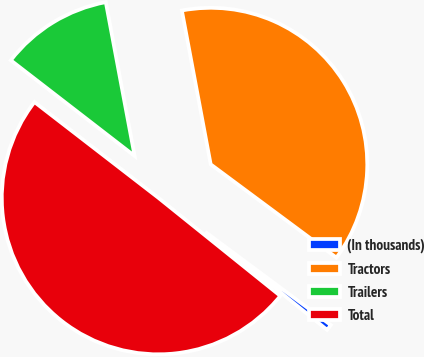Convert chart. <chart><loc_0><loc_0><loc_500><loc_500><pie_chart><fcel>(In thousands)<fcel>Tractors<fcel>Trailers<fcel>Total<nl><fcel>0.62%<fcel>38.11%<fcel>11.58%<fcel>49.69%<nl></chart> 